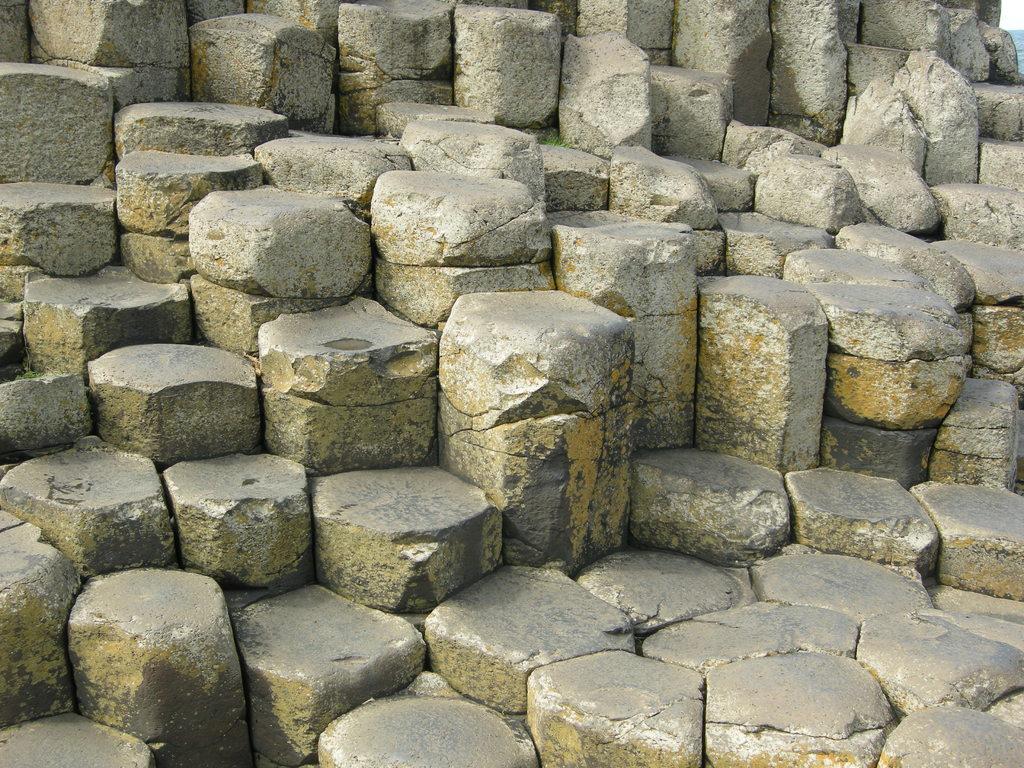Describe this image in one or two sentences. In this picture we can see many concrete blocks in the image. 